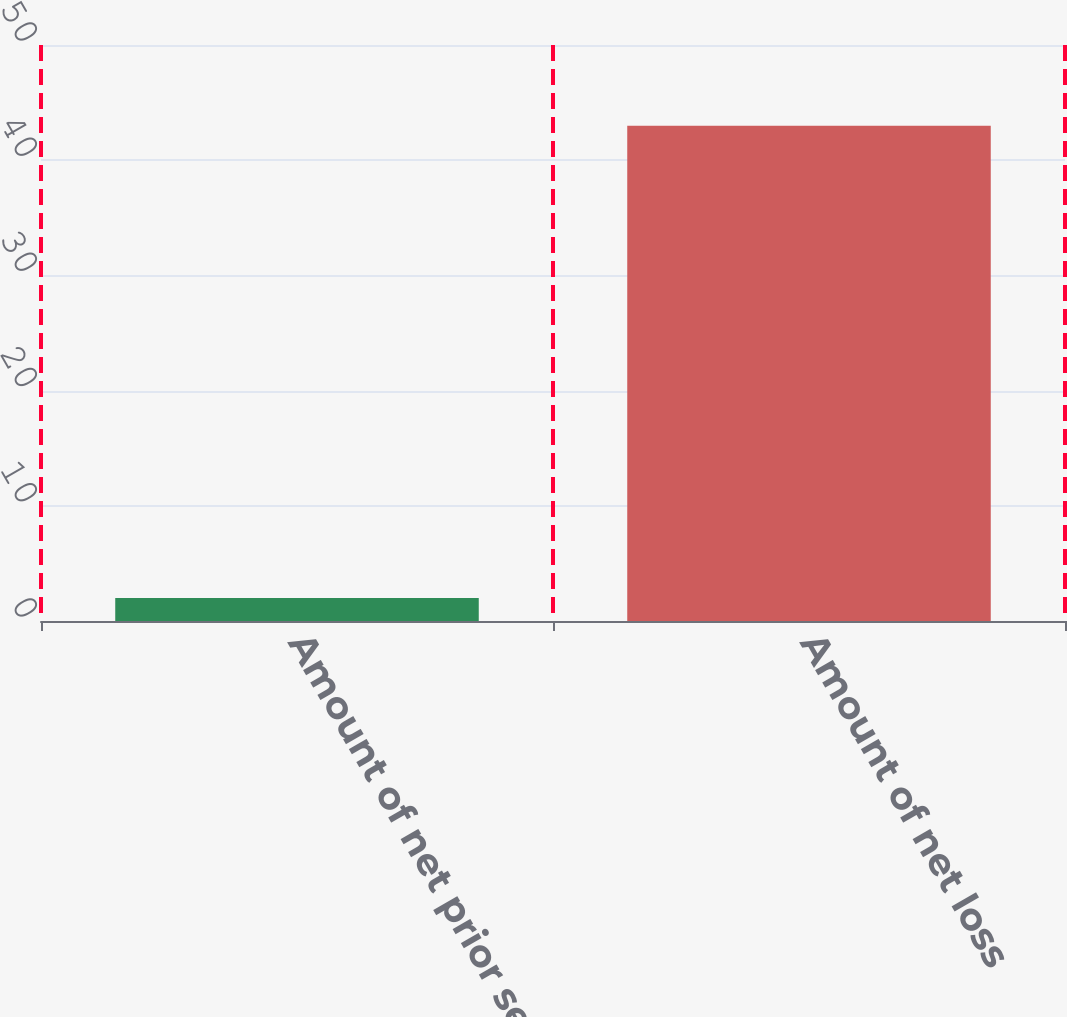Convert chart. <chart><loc_0><loc_0><loc_500><loc_500><bar_chart><fcel>Amount of net prior service<fcel>Amount of net loss<nl><fcel>2<fcel>43<nl></chart> 